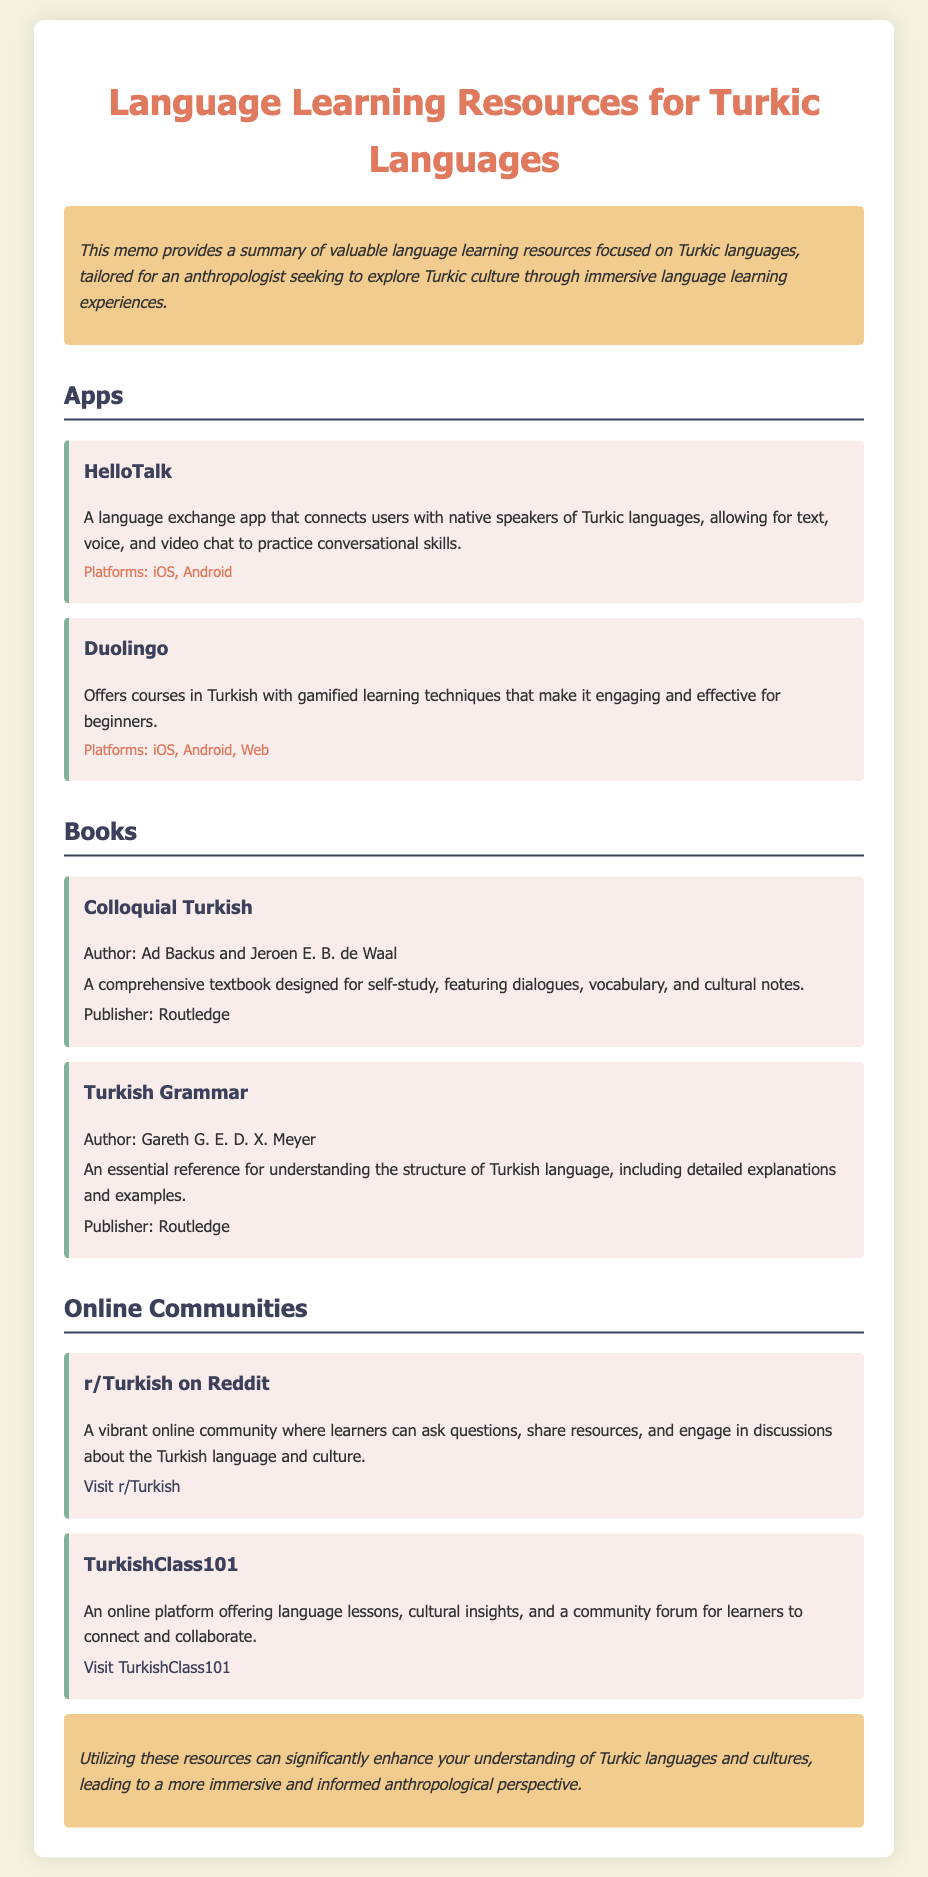what is the title of the memo? The title of the memo is the first heading in the document and provides the main topic of discussion, which is "Language Learning Resources for Turkic Languages."
Answer: Language Learning Resources for Turkic Languages who are the authors of "Colloquial Turkish"? The authors' names are mentioned directly under the book title in the resource section of the memo.
Answer: Ad Backus and Jeroen E. B. de Waal which app connects users with native speakers of Turkic languages? This information is found in the Apps section, specifically under the description of a particular resource.
Answer: HelloTalk how many platforms does Duolingo support? The document states the platforms available for Duolingo in its description, but it does not provide a specific number. However, it mentions that it is available on iOS, Android, and Web.
Answer: iOS, Android, Web what is the primary benefit of utilizing the resources listed? The conclusion section summarizes the main advantage of using the resources discussed throughout the memo.
Answer: Enhance understanding of Turkic languages and cultures what type of platform is TurkishClass101? The document provides the type of platform in its description under the Online Communities section.
Answer: Online platform how can learners engage with others in the r/Turkish community? The memo explains the nature of the community and its purpose for learners, focusing on interaction and learning.
Answer: Ask questions, share resources, engage in discussions what publishing company released "Turkish Grammar"? The publisher's name is provided in the resource section under the book title.
Answer: Routledge 